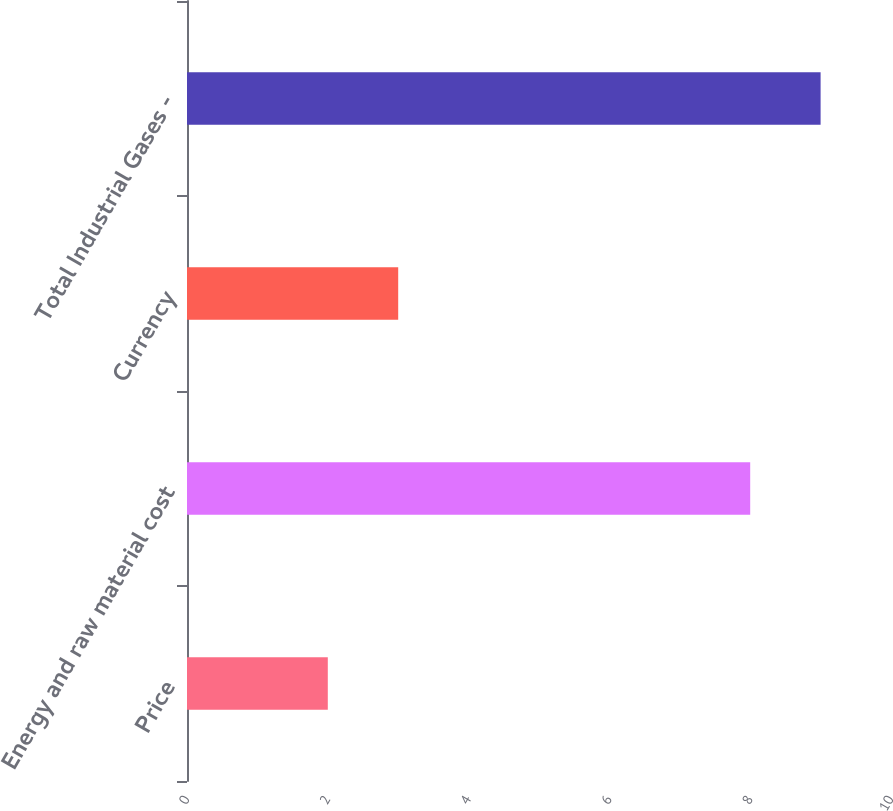<chart> <loc_0><loc_0><loc_500><loc_500><bar_chart><fcel>Price<fcel>Energy and raw material cost<fcel>Currency<fcel>Total Industrial Gases -<nl><fcel>2<fcel>8<fcel>3<fcel>9<nl></chart> 